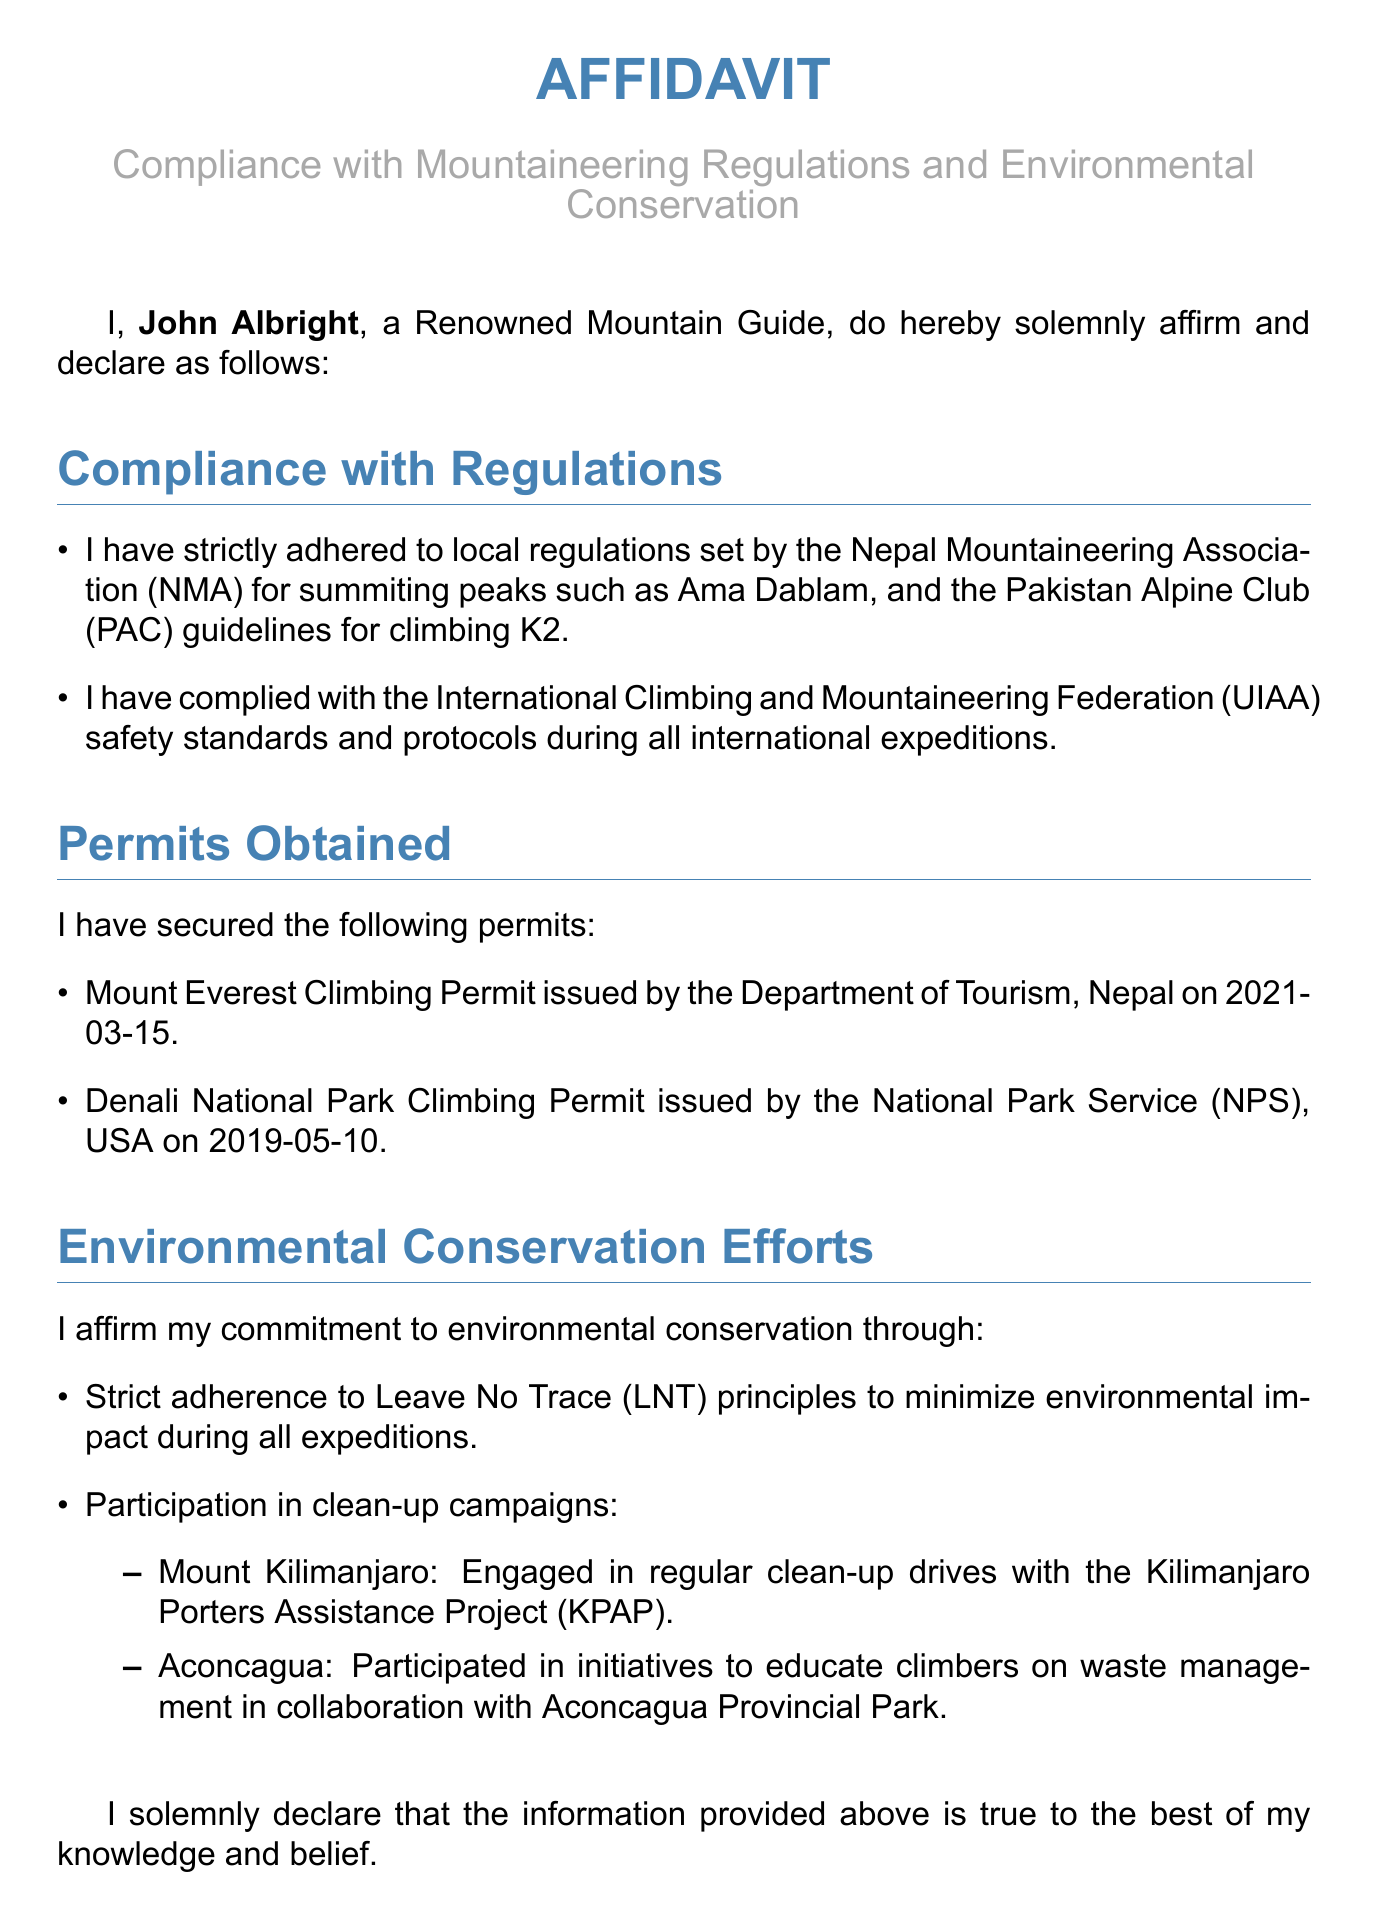What is the full name of the affiant? The affiant identifies himself as John Albright in the document.
Answer: John Albright What regulations does John Albright comply with for Ama Dablam? The document states that he adheres to local regulations set by the Nepal Mountaineering Association (NMA) for Ama Dablam.
Answer: Nepal Mountaineering Association (NMA) When was the Mount Everest Climbing Permit issued? The document specifies that the permit was issued on 2021-03-15.
Answer: 2021-03-15 Which environmental principle does John Albright follow? The document mentions his strict adherence to Leave No Trace principles.
Answer: Leave No Trace (LNT) What organization issued the Denali National Park Climbing Permit? The National Park Service (NPS) issued the permit according to the document.
Answer: National Park Service (NPS) Which peak's clean-up campaign did John participate in? The document details his engagement in clean-up drives on Mount Kilimanjaro.
Answer: Mount Kilimanjaro How many permits has John Albright secured in total? The document lists two permits obtained by him.
Answer: Two What international federation's safety standards does John comply with? The document refers to the International Climbing and Mountaineering Federation.
Answer: International Climbing and Mountaineering Federation (UIAA) What type of document is this? This document is an affidavit, as stated in the title.
Answer: Affidavit 